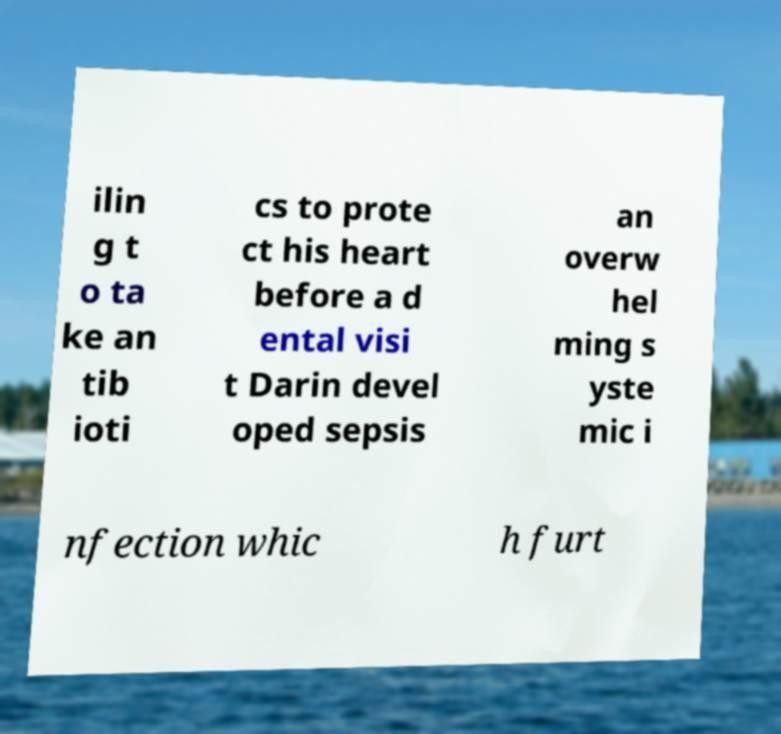Could you extract and type out the text from this image? ilin g t o ta ke an tib ioti cs to prote ct his heart before a d ental visi t Darin devel oped sepsis an overw hel ming s yste mic i nfection whic h furt 